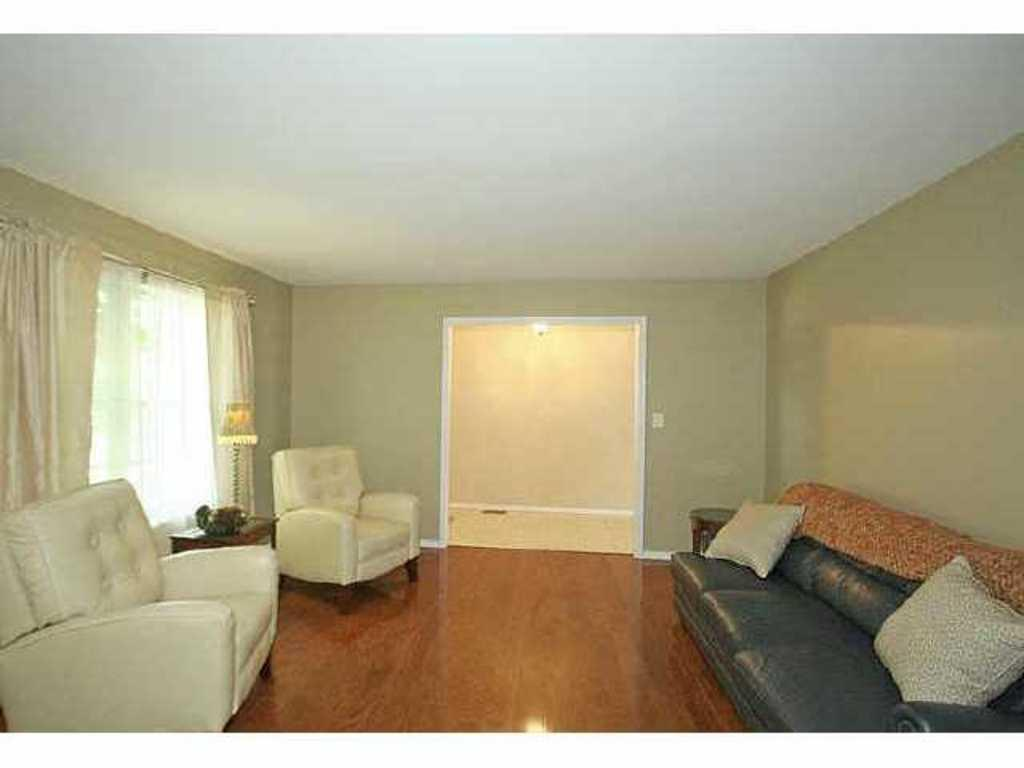What type of room is depicted in the image? There is a living room in the image. What furniture can be seen in the living room? There are chairs and a sofa in the living room. What type of bells are hanging on the sofa in the image? There are no bells present in the image; the sofa is not adorned with any bells. 